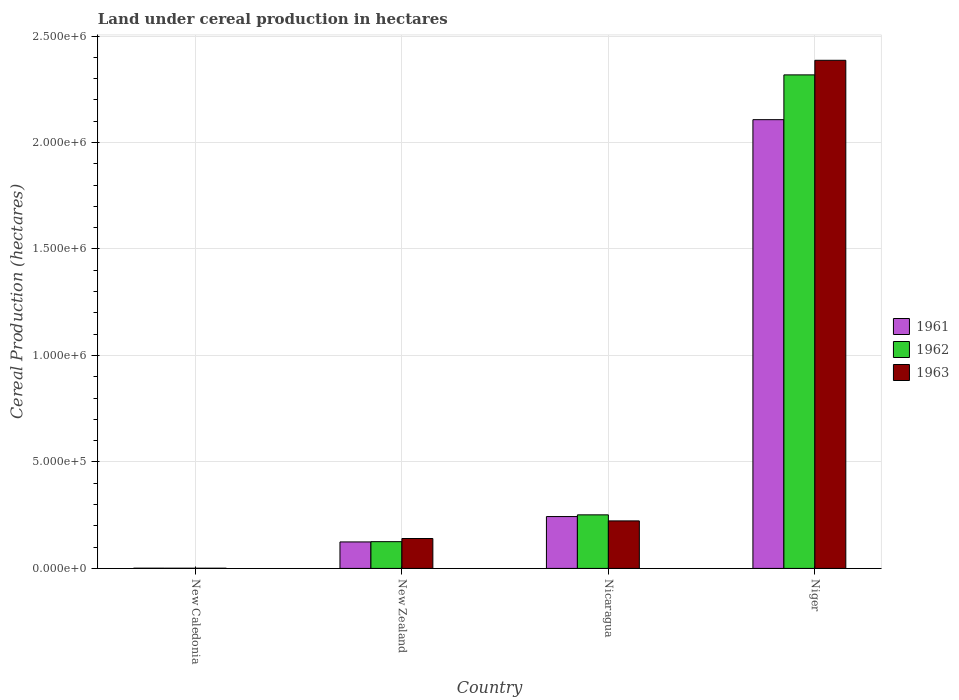How many different coloured bars are there?
Give a very brief answer. 3. Are the number of bars per tick equal to the number of legend labels?
Keep it short and to the point. Yes. What is the label of the 3rd group of bars from the left?
Ensure brevity in your answer.  Nicaragua. In how many cases, is the number of bars for a given country not equal to the number of legend labels?
Offer a very short reply. 0. What is the land under cereal production in 1962 in New Zealand?
Offer a very short reply. 1.26e+05. Across all countries, what is the maximum land under cereal production in 1961?
Offer a very short reply. 2.11e+06. Across all countries, what is the minimum land under cereal production in 1963?
Make the answer very short. 900. In which country was the land under cereal production in 1961 maximum?
Offer a very short reply. Niger. In which country was the land under cereal production in 1962 minimum?
Your response must be concise. New Caledonia. What is the total land under cereal production in 1961 in the graph?
Provide a succinct answer. 2.48e+06. What is the difference between the land under cereal production in 1962 in Nicaragua and that in Niger?
Offer a very short reply. -2.07e+06. What is the difference between the land under cereal production in 1962 in Niger and the land under cereal production in 1961 in Nicaragua?
Offer a terse response. 2.07e+06. What is the average land under cereal production in 1963 per country?
Offer a very short reply. 6.88e+05. What is the difference between the land under cereal production of/in 1962 and land under cereal production of/in 1963 in Nicaragua?
Offer a very short reply. 2.84e+04. In how many countries, is the land under cereal production in 1963 greater than 1500000 hectares?
Your response must be concise. 1. What is the ratio of the land under cereal production in 1963 in Nicaragua to that in Niger?
Offer a terse response. 0.09. What is the difference between the highest and the second highest land under cereal production in 1962?
Ensure brevity in your answer.  2.07e+06. What is the difference between the highest and the lowest land under cereal production in 1961?
Give a very brief answer. 2.11e+06. In how many countries, is the land under cereal production in 1962 greater than the average land under cereal production in 1962 taken over all countries?
Make the answer very short. 1. What does the 1st bar from the right in Niger represents?
Your answer should be very brief. 1963. Is it the case that in every country, the sum of the land under cereal production in 1962 and land under cereal production in 1961 is greater than the land under cereal production in 1963?
Your answer should be compact. Yes. How many bars are there?
Make the answer very short. 12. What is the difference between two consecutive major ticks on the Y-axis?
Offer a very short reply. 5.00e+05. Are the values on the major ticks of Y-axis written in scientific E-notation?
Provide a short and direct response. Yes. Does the graph contain grids?
Ensure brevity in your answer.  Yes. Where does the legend appear in the graph?
Make the answer very short. Center right. What is the title of the graph?
Offer a very short reply. Land under cereal production in hectares. What is the label or title of the Y-axis?
Offer a very short reply. Cereal Production (hectares). What is the Cereal Production (hectares) in 1961 in New Caledonia?
Provide a succinct answer. 1050. What is the Cereal Production (hectares) in 1962 in New Caledonia?
Your response must be concise. 950. What is the Cereal Production (hectares) of 1963 in New Caledonia?
Your response must be concise. 900. What is the Cereal Production (hectares) in 1961 in New Zealand?
Your response must be concise. 1.24e+05. What is the Cereal Production (hectares) of 1962 in New Zealand?
Your answer should be compact. 1.26e+05. What is the Cereal Production (hectares) in 1963 in New Zealand?
Offer a very short reply. 1.40e+05. What is the Cereal Production (hectares) in 1961 in Nicaragua?
Keep it short and to the point. 2.44e+05. What is the Cereal Production (hectares) in 1962 in Nicaragua?
Keep it short and to the point. 2.52e+05. What is the Cereal Production (hectares) in 1963 in Nicaragua?
Your answer should be very brief. 2.23e+05. What is the Cereal Production (hectares) in 1961 in Niger?
Provide a succinct answer. 2.11e+06. What is the Cereal Production (hectares) in 1962 in Niger?
Your answer should be compact. 2.32e+06. What is the Cereal Production (hectares) in 1963 in Niger?
Offer a terse response. 2.39e+06. Across all countries, what is the maximum Cereal Production (hectares) in 1961?
Your answer should be very brief. 2.11e+06. Across all countries, what is the maximum Cereal Production (hectares) in 1962?
Your answer should be compact. 2.32e+06. Across all countries, what is the maximum Cereal Production (hectares) in 1963?
Your answer should be compact. 2.39e+06. Across all countries, what is the minimum Cereal Production (hectares) of 1961?
Provide a short and direct response. 1050. Across all countries, what is the minimum Cereal Production (hectares) in 1962?
Keep it short and to the point. 950. Across all countries, what is the minimum Cereal Production (hectares) of 1963?
Offer a terse response. 900. What is the total Cereal Production (hectares) in 1961 in the graph?
Make the answer very short. 2.48e+06. What is the total Cereal Production (hectares) of 1962 in the graph?
Make the answer very short. 2.70e+06. What is the total Cereal Production (hectares) in 1963 in the graph?
Keep it short and to the point. 2.75e+06. What is the difference between the Cereal Production (hectares) in 1961 in New Caledonia and that in New Zealand?
Ensure brevity in your answer.  -1.23e+05. What is the difference between the Cereal Production (hectares) in 1962 in New Caledonia and that in New Zealand?
Give a very brief answer. -1.25e+05. What is the difference between the Cereal Production (hectares) of 1963 in New Caledonia and that in New Zealand?
Provide a succinct answer. -1.39e+05. What is the difference between the Cereal Production (hectares) of 1961 in New Caledonia and that in Nicaragua?
Provide a succinct answer. -2.42e+05. What is the difference between the Cereal Production (hectares) in 1962 in New Caledonia and that in Nicaragua?
Make the answer very short. -2.51e+05. What is the difference between the Cereal Production (hectares) of 1963 in New Caledonia and that in Nicaragua?
Your response must be concise. -2.22e+05. What is the difference between the Cereal Production (hectares) in 1961 in New Caledonia and that in Niger?
Offer a terse response. -2.11e+06. What is the difference between the Cereal Production (hectares) in 1962 in New Caledonia and that in Niger?
Make the answer very short. -2.32e+06. What is the difference between the Cereal Production (hectares) of 1963 in New Caledonia and that in Niger?
Keep it short and to the point. -2.39e+06. What is the difference between the Cereal Production (hectares) in 1961 in New Zealand and that in Nicaragua?
Give a very brief answer. -1.19e+05. What is the difference between the Cereal Production (hectares) of 1962 in New Zealand and that in Nicaragua?
Offer a terse response. -1.26e+05. What is the difference between the Cereal Production (hectares) in 1963 in New Zealand and that in Nicaragua?
Make the answer very short. -8.27e+04. What is the difference between the Cereal Production (hectares) in 1961 in New Zealand and that in Niger?
Provide a short and direct response. -1.98e+06. What is the difference between the Cereal Production (hectares) in 1962 in New Zealand and that in Niger?
Offer a very short reply. -2.19e+06. What is the difference between the Cereal Production (hectares) in 1963 in New Zealand and that in Niger?
Make the answer very short. -2.25e+06. What is the difference between the Cereal Production (hectares) in 1961 in Nicaragua and that in Niger?
Provide a succinct answer. -1.86e+06. What is the difference between the Cereal Production (hectares) of 1962 in Nicaragua and that in Niger?
Your answer should be compact. -2.07e+06. What is the difference between the Cereal Production (hectares) in 1963 in Nicaragua and that in Niger?
Make the answer very short. -2.16e+06. What is the difference between the Cereal Production (hectares) of 1961 in New Caledonia and the Cereal Production (hectares) of 1962 in New Zealand?
Ensure brevity in your answer.  -1.25e+05. What is the difference between the Cereal Production (hectares) in 1961 in New Caledonia and the Cereal Production (hectares) in 1963 in New Zealand?
Keep it short and to the point. -1.39e+05. What is the difference between the Cereal Production (hectares) of 1962 in New Caledonia and the Cereal Production (hectares) of 1963 in New Zealand?
Give a very brief answer. -1.39e+05. What is the difference between the Cereal Production (hectares) in 1961 in New Caledonia and the Cereal Production (hectares) in 1962 in Nicaragua?
Make the answer very short. -2.50e+05. What is the difference between the Cereal Production (hectares) of 1961 in New Caledonia and the Cereal Production (hectares) of 1963 in Nicaragua?
Ensure brevity in your answer.  -2.22e+05. What is the difference between the Cereal Production (hectares) of 1962 in New Caledonia and the Cereal Production (hectares) of 1963 in Nicaragua?
Your answer should be compact. -2.22e+05. What is the difference between the Cereal Production (hectares) in 1961 in New Caledonia and the Cereal Production (hectares) in 1962 in Niger?
Provide a succinct answer. -2.32e+06. What is the difference between the Cereal Production (hectares) of 1961 in New Caledonia and the Cereal Production (hectares) of 1963 in Niger?
Ensure brevity in your answer.  -2.38e+06. What is the difference between the Cereal Production (hectares) in 1962 in New Caledonia and the Cereal Production (hectares) in 1963 in Niger?
Your answer should be very brief. -2.39e+06. What is the difference between the Cereal Production (hectares) of 1961 in New Zealand and the Cereal Production (hectares) of 1962 in Nicaragua?
Your answer should be very brief. -1.27e+05. What is the difference between the Cereal Production (hectares) in 1961 in New Zealand and the Cereal Production (hectares) in 1963 in Nicaragua?
Ensure brevity in your answer.  -9.87e+04. What is the difference between the Cereal Production (hectares) in 1962 in New Zealand and the Cereal Production (hectares) in 1963 in Nicaragua?
Offer a terse response. -9.75e+04. What is the difference between the Cereal Production (hectares) in 1961 in New Zealand and the Cereal Production (hectares) in 1962 in Niger?
Offer a terse response. -2.19e+06. What is the difference between the Cereal Production (hectares) of 1961 in New Zealand and the Cereal Production (hectares) of 1963 in Niger?
Provide a succinct answer. -2.26e+06. What is the difference between the Cereal Production (hectares) in 1962 in New Zealand and the Cereal Production (hectares) in 1963 in Niger?
Offer a terse response. -2.26e+06. What is the difference between the Cereal Production (hectares) of 1961 in Nicaragua and the Cereal Production (hectares) of 1962 in Niger?
Offer a very short reply. -2.07e+06. What is the difference between the Cereal Production (hectares) of 1961 in Nicaragua and the Cereal Production (hectares) of 1963 in Niger?
Provide a succinct answer. -2.14e+06. What is the difference between the Cereal Production (hectares) of 1962 in Nicaragua and the Cereal Production (hectares) of 1963 in Niger?
Keep it short and to the point. -2.13e+06. What is the average Cereal Production (hectares) of 1961 per country?
Provide a short and direct response. 6.19e+05. What is the average Cereal Production (hectares) of 1962 per country?
Offer a terse response. 6.74e+05. What is the average Cereal Production (hectares) in 1963 per country?
Give a very brief answer. 6.88e+05. What is the difference between the Cereal Production (hectares) in 1961 and Cereal Production (hectares) in 1963 in New Caledonia?
Your answer should be very brief. 150. What is the difference between the Cereal Production (hectares) of 1961 and Cereal Production (hectares) of 1962 in New Zealand?
Ensure brevity in your answer.  -1208. What is the difference between the Cereal Production (hectares) of 1961 and Cereal Production (hectares) of 1963 in New Zealand?
Provide a short and direct response. -1.60e+04. What is the difference between the Cereal Production (hectares) of 1962 and Cereal Production (hectares) of 1963 in New Zealand?
Provide a short and direct response. -1.48e+04. What is the difference between the Cereal Production (hectares) in 1961 and Cereal Production (hectares) in 1962 in Nicaragua?
Provide a succinct answer. -8000. What is the difference between the Cereal Production (hectares) in 1961 and Cereal Production (hectares) in 1963 in Nicaragua?
Your response must be concise. 2.04e+04. What is the difference between the Cereal Production (hectares) in 1962 and Cereal Production (hectares) in 1963 in Nicaragua?
Offer a terse response. 2.84e+04. What is the difference between the Cereal Production (hectares) in 1961 and Cereal Production (hectares) in 1962 in Niger?
Offer a very short reply. -2.10e+05. What is the difference between the Cereal Production (hectares) in 1961 and Cereal Production (hectares) in 1963 in Niger?
Keep it short and to the point. -2.79e+05. What is the difference between the Cereal Production (hectares) of 1962 and Cereal Production (hectares) of 1963 in Niger?
Offer a very short reply. -6.85e+04. What is the ratio of the Cereal Production (hectares) of 1961 in New Caledonia to that in New Zealand?
Make the answer very short. 0.01. What is the ratio of the Cereal Production (hectares) of 1962 in New Caledonia to that in New Zealand?
Provide a succinct answer. 0.01. What is the ratio of the Cereal Production (hectares) in 1963 in New Caledonia to that in New Zealand?
Make the answer very short. 0.01. What is the ratio of the Cereal Production (hectares) of 1961 in New Caledonia to that in Nicaragua?
Keep it short and to the point. 0. What is the ratio of the Cereal Production (hectares) of 1962 in New Caledonia to that in Nicaragua?
Your response must be concise. 0. What is the ratio of the Cereal Production (hectares) in 1963 in New Caledonia to that in Nicaragua?
Give a very brief answer. 0. What is the ratio of the Cereal Production (hectares) in 1961 in New Caledonia to that in Niger?
Ensure brevity in your answer.  0. What is the ratio of the Cereal Production (hectares) of 1961 in New Zealand to that in Nicaragua?
Your answer should be compact. 0.51. What is the ratio of the Cereal Production (hectares) of 1962 in New Zealand to that in Nicaragua?
Your answer should be compact. 0.5. What is the ratio of the Cereal Production (hectares) in 1963 in New Zealand to that in Nicaragua?
Your response must be concise. 0.63. What is the ratio of the Cereal Production (hectares) in 1961 in New Zealand to that in Niger?
Provide a succinct answer. 0.06. What is the ratio of the Cereal Production (hectares) in 1962 in New Zealand to that in Niger?
Offer a terse response. 0.05. What is the ratio of the Cereal Production (hectares) in 1963 in New Zealand to that in Niger?
Provide a short and direct response. 0.06. What is the ratio of the Cereal Production (hectares) of 1961 in Nicaragua to that in Niger?
Your answer should be very brief. 0.12. What is the ratio of the Cereal Production (hectares) of 1962 in Nicaragua to that in Niger?
Keep it short and to the point. 0.11. What is the ratio of the Cereal Production (hectares) of 1963 in Nicaragua to that in Niger?
Provide a short and direct response. 0.09. What is the difference between the highest and the second highest Cereal Production (hectares) in 1961?
Your answer should be very brief. 1.86e+06. What is the difference between the highest and the second highest Cereal Production (hectares) in 1962?
Your answer should be compact. 2.07e+06. What is the difference between the highest and the second highest Cereal Production (hectares) in 1963?
Ensure brevity in your answer.  2.16e+06. What is the difference between the highest and the lowest Cereal Production (hectares) in 1961?
Give a very brief answer. 2.11e+06. What is the difference between the highest and the lowest Cereal Production (hectares) of 1962?
Offer a terse response. 2.32e+06. What is the difference between the highest and the lowest Cereal Production (hectares) of 1963?
Provide a short and direct response. 2.39e+06. 